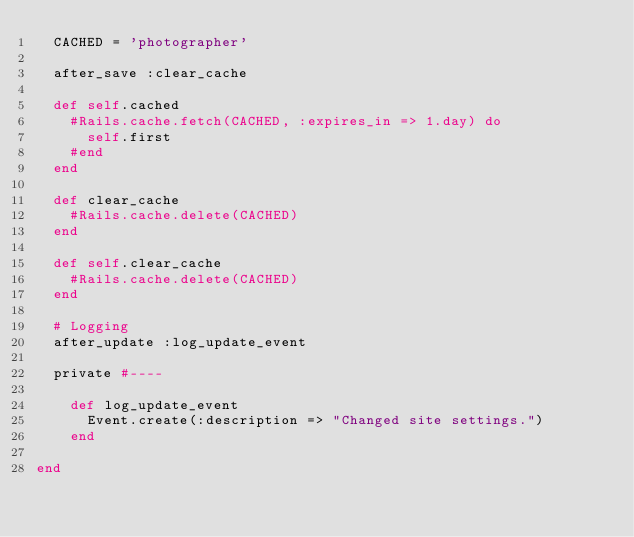<code> <loc_0><loc_0><loc_500><loc_500><_Ruby_>  CACHED = 'photographer'

  after_save :clear_cache

  def self.cached
    #Rails.cache.fetch(CACHED, :expires_in => 1.day) do
      self.first
    #end
  end

  def clear_cache
    #Rails.cache.delete(CACHED)
  end

  def self.clear_cache
    #Rails.cache.delete(CACHED)
  end

  # Logging
  after_update :log_update_event

  private #----

    def log_update_event
      Event.create(:description => "Changed site settings.")
    end

end
</code> 